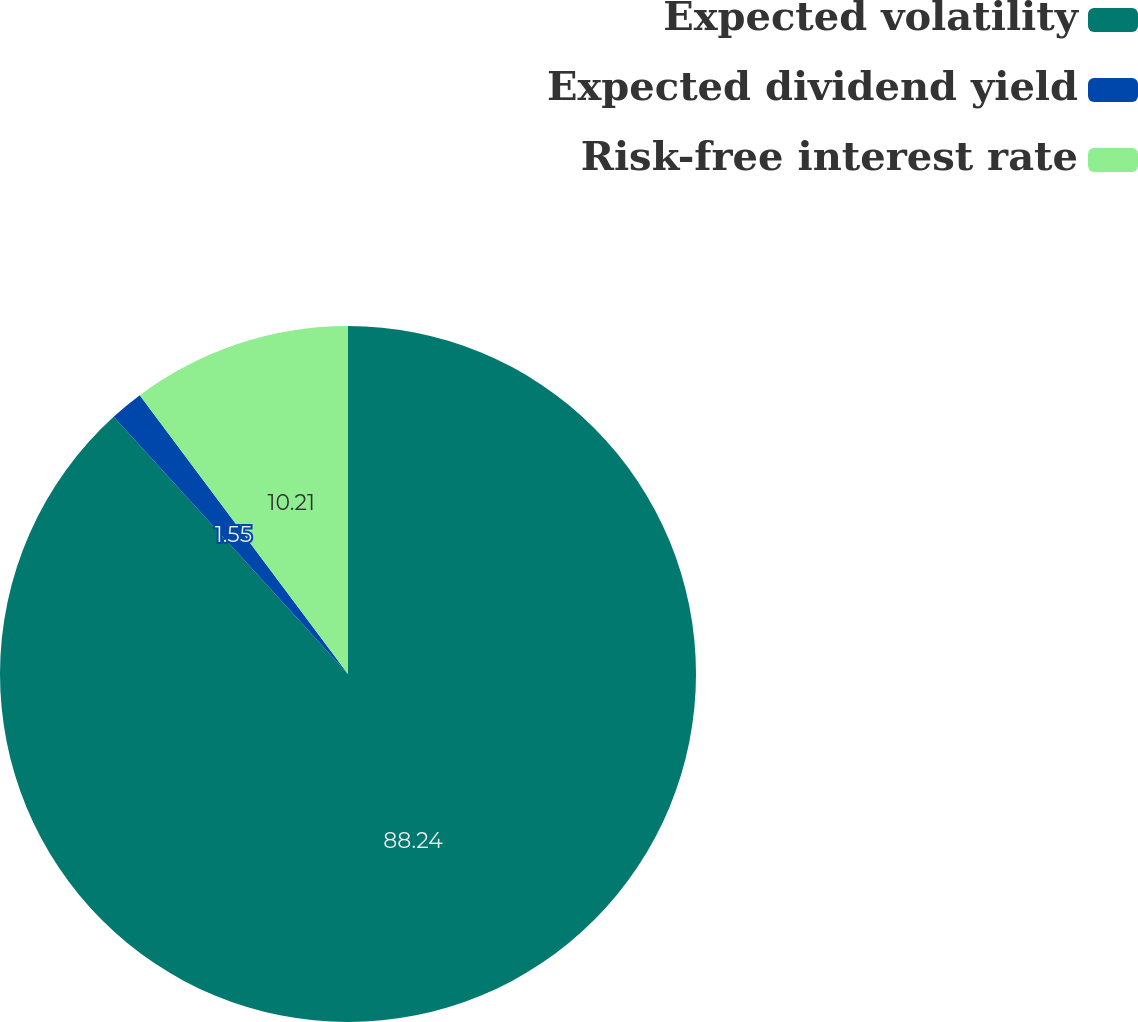<chart> <loc_0><loc_0><loc_500><loc_500><pie_chart><fcel>Expected volatility<fcel>Expected dividend yield<fcel>Risk-free interest rate<nl><fcel>88.24%<fcel>1.55%<fcel>10.21%<nl></chart> 